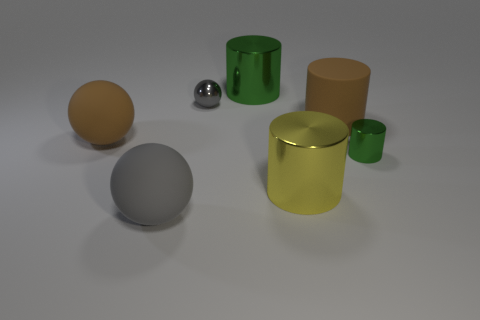Subtract all red cubes. How many green cylinders are left? 2 Subtract all large spheres. How many spheres are left? 1 Add 3 large yellow metallic things. How many objects exist? 10 Subtract all brown cylinders. How many cylinders are left? 3 Subtract all spheres. How many objects are left? 4 Subtract 3 cylinders. How many cylinders are left? 1 Subtract 0 cyan cubes. How many objects are left? 7 Subtract all gray balls. Subtract all gray blocks. How many balls are left? 1 Subtract all small purple matte balls. Subtract all large matte cylinders. How many objects are left? 6 Add 7 yellow metallic cylinders. How many yellow metallic cylinders are left? 8 